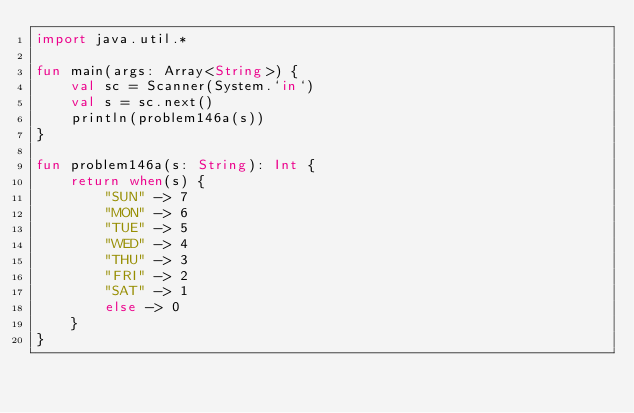<code> <loc_0><loc_0><loc_500><loc_500><_Kotlin_>import java.util.*

fun main(args: Array<String>) {
    val sc = Scanner(System.`in`)
    val s = sc.next()
    println(problem146a(s))
}

fun problem146a(s: String): Int {
    return when(s) {
        "SUN" -> 7
        "MON" -> 6
        "TUE" -> 5
        "WED" -> 4
        "THU" -> 3
        "FRI" -> 2
        "SAT" -> 1
        else -> 0
    }
}</code> 